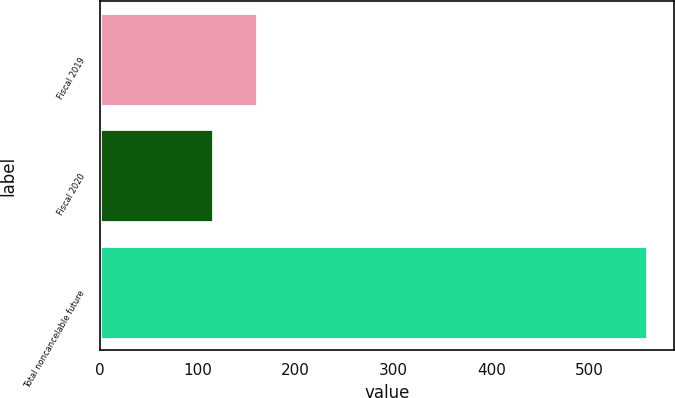Convert chart. <chart><loc_0><loc_0><loc_500><loc_500><bar_chart><fcel>Fiscal 2019<fcel>Fiscal 2020<fcel>Total noncancelable future<nl><fcel>160.06<fcel>115.7<fcel>559.3<nl></chart> 